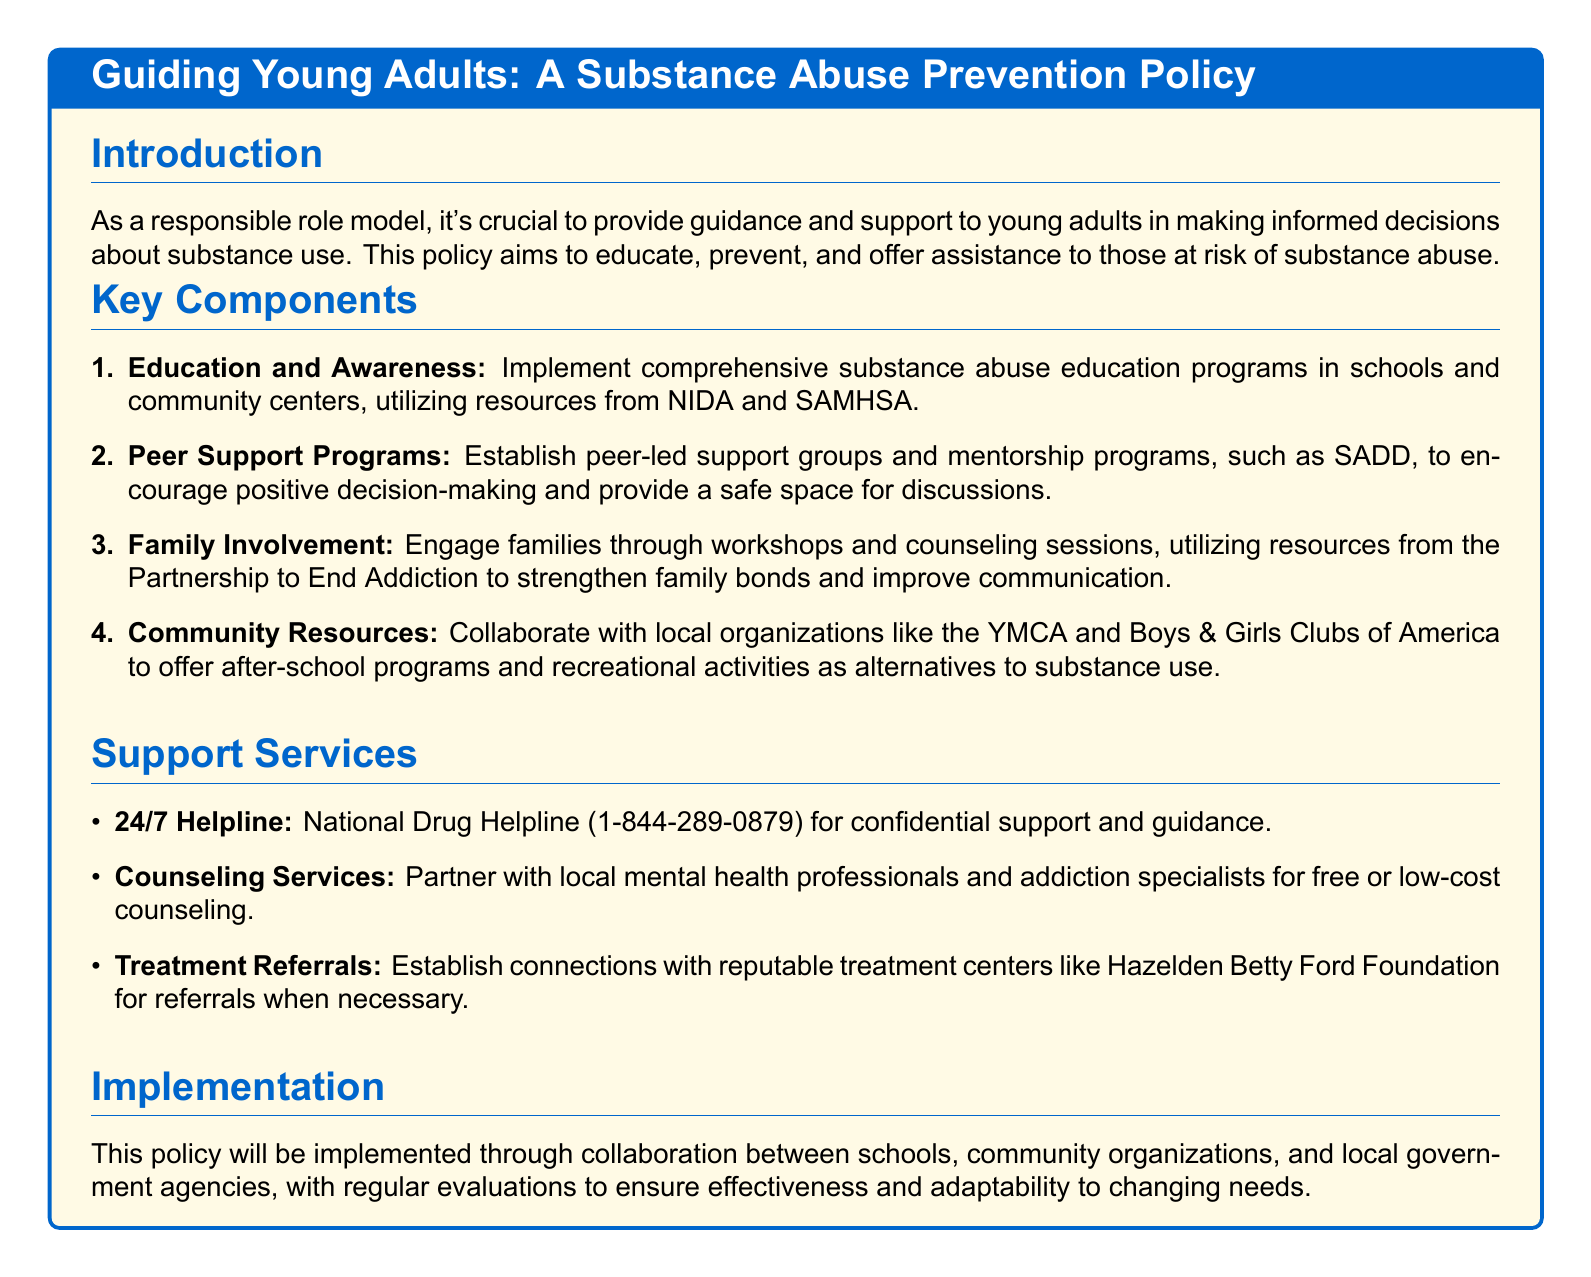What is the main goal of the policy? The main goal of the policy is to educate, prevent, and offer assistance to those at risk of substance abuse.
Answer: Educate, prevent, and offer assistance How many key components are listed in the document? The document outlines a total of four key components.
Answer: Four What does NIDA stand for? NIDA is referred to in the document as a source for education programs.
Answer: National Institute on Drug Abuse Which peer support program is mentioned? The document specifically mentions SADD as a peer-led support group.
Answer: SADD What service is available 24/7 for support? The document mentions the National Drug Helpline as a 24/7 support service.
Answer: National Drug Helpline What type of professionals are partnered with for counseling services? The document states that local mental health professionals are partnered for counseling services.
Answer: Mental health professionals Which organization is cited for family involvement resources? The Partnership to End Addiction is referenced for resources related to family involvement.
Answer: Partnership to End Addiction What type of activities are offered by local organizations? The document indicates that after-school programs and recreational activities are offered as alternatives to substance use.
Answer: After-school programs and recreational activities How does the policy aim to implement the components? The implementation involves collaboration between schools, community organizations, and local government agencies.
Answer: Collaboration between schools, community organizations, and local government agencies 